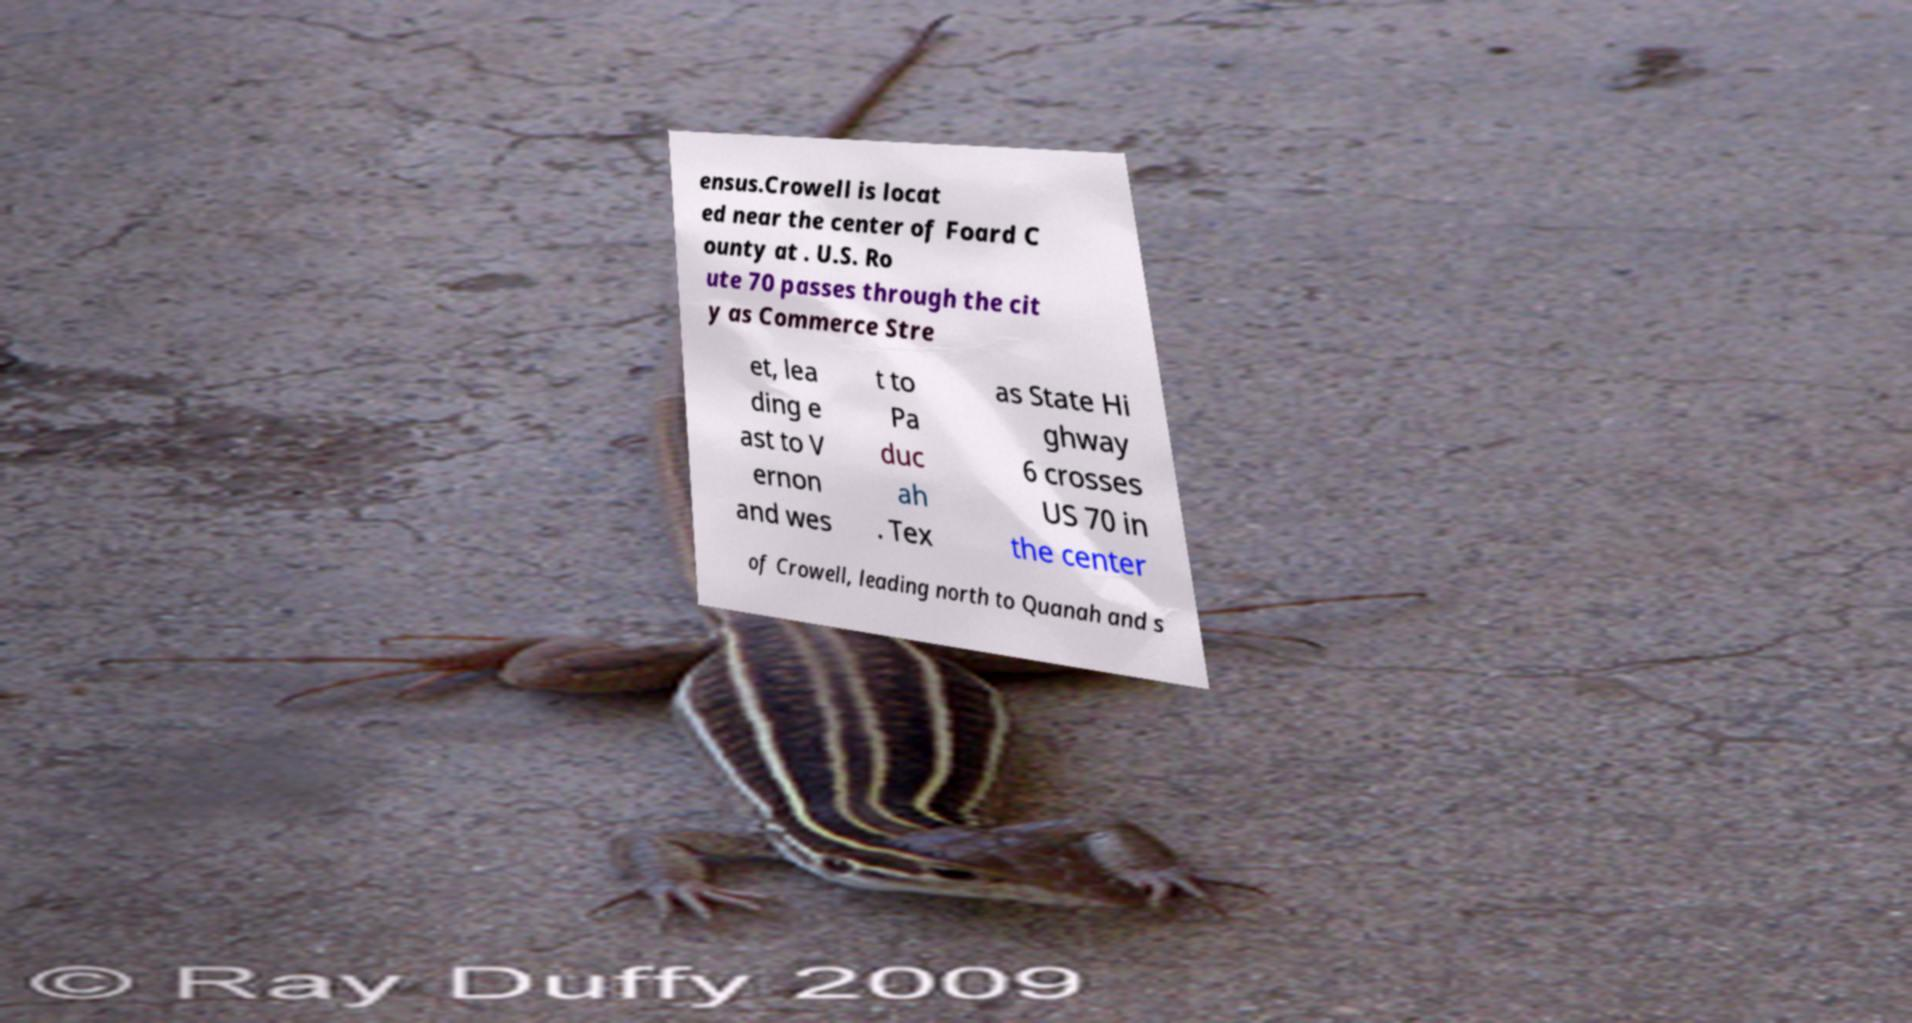For documentation purposes, I need the text within this image transcribed. Could you provide that? ensus.Crowell is locat ed near the center of Foard C ounty at . U.S. Ro ute 70 passes through the cit y as Commerce Stre et, lea ding e ast to V ernon and wes t to Pa duc ah . Tex as State Hi ghway 6 crosses US 70 in the center of Crowell, leading north to Quanah and s 